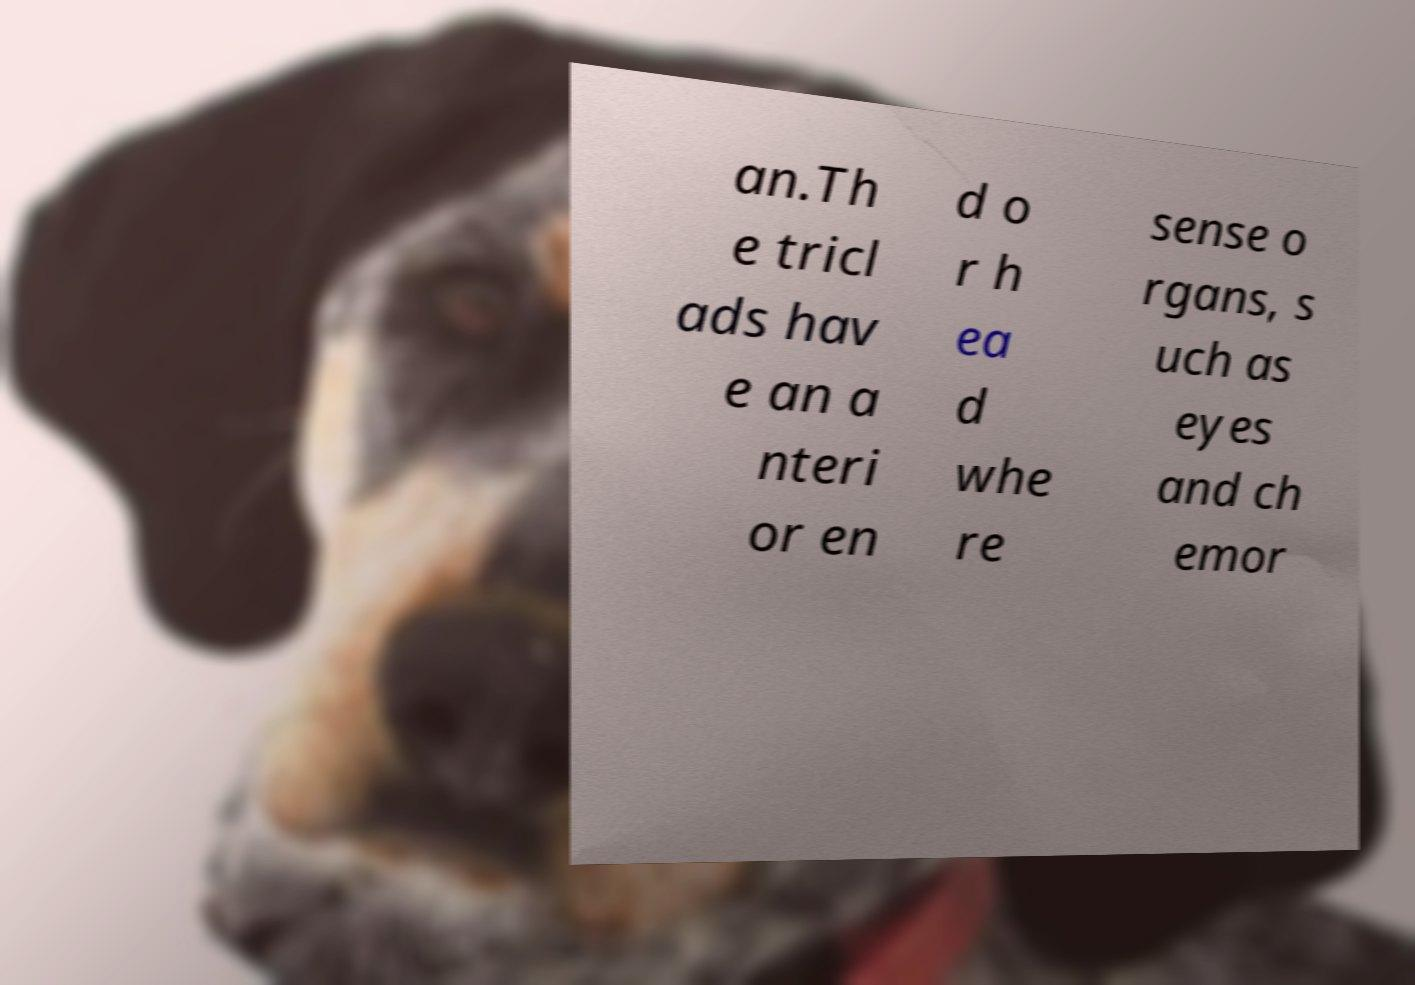Can you read and provide the text displayed in the image?This photo seems to have some interesting text. Can you extract and type it out for me? an.Th e tricl ads hav e an a nteri or en d o r h ea d whe re sense o rgans, s uch as eyes and ch emor 